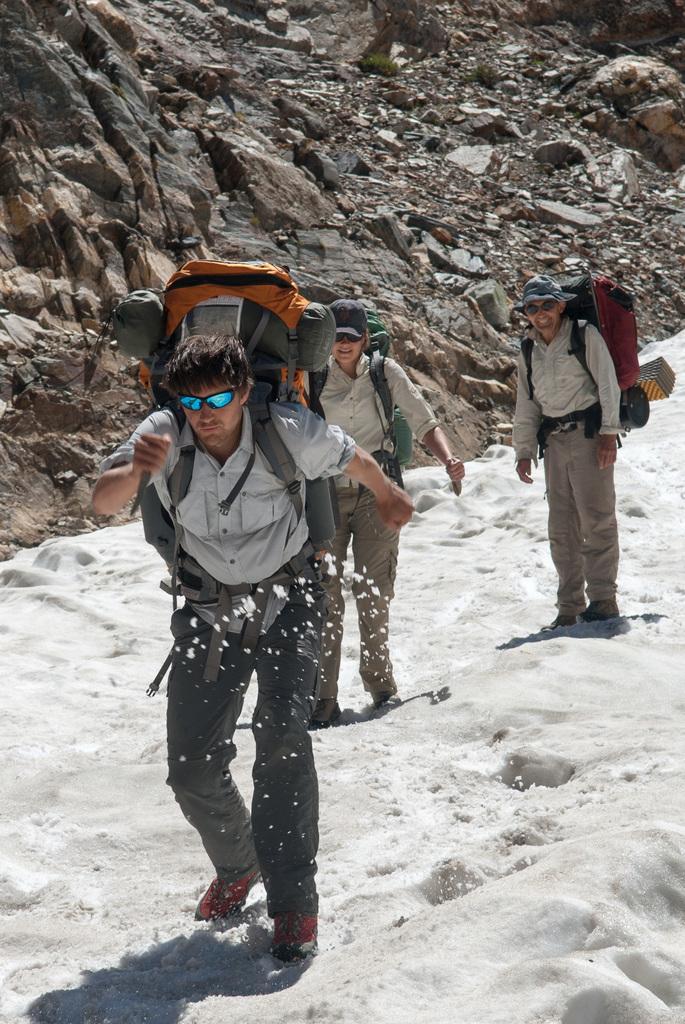Please provide a concise description of this image. There are three people standing. They wear backpack bags, shirts, trousers and shoes. I think this is the snow. This looks like a mountain with the rocks. 